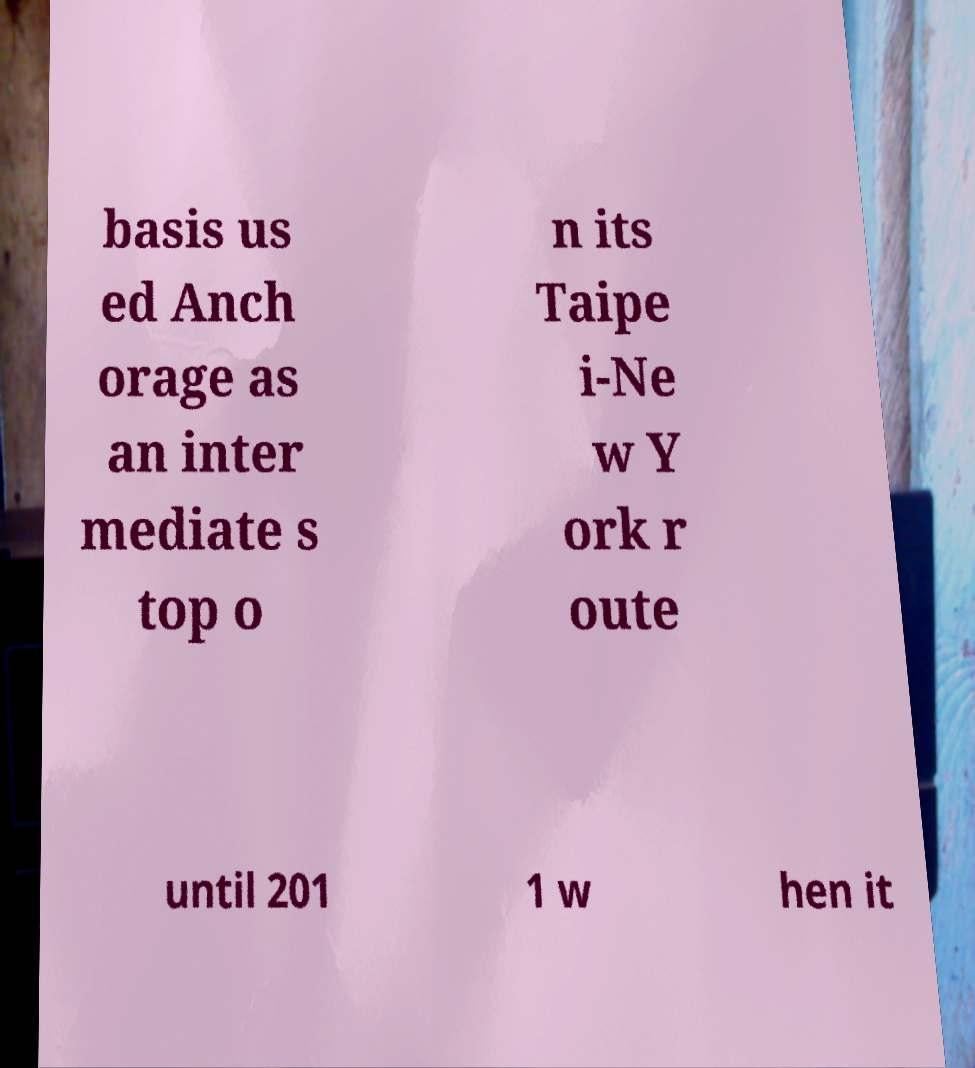Please identify and transcribe the text found in this image. basis us ed Anch orage as an inter mediate s top o n its Taipe i-Ne w Y ork r oute until 201 1 w hen it 